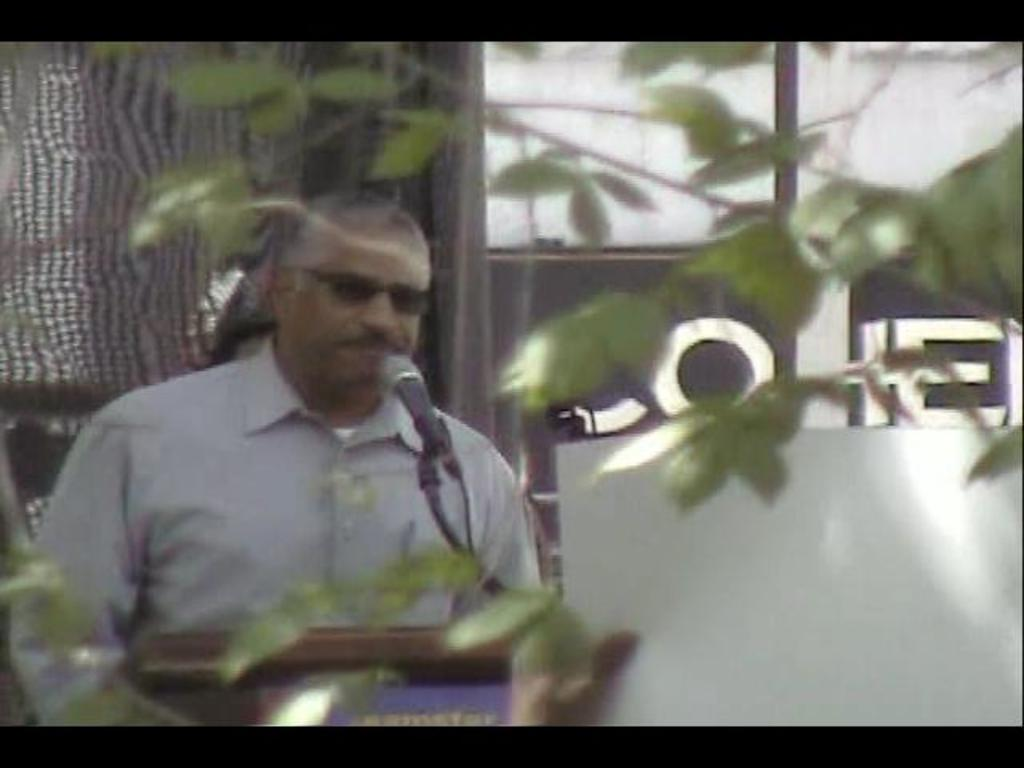What is the person wearing in the image? The person is wearing a white shirt in the image. What object is present that is commonly used for amplifying sound? There is a microphone (mic) in the image. What type of object can be seen in the image that is used for transmitting sound or electricity? There is a wire in the image. What type of vegetation can be seen in the image? There are green leaves visible in the image. What color and pattern can be seen in the background of the image? There is a brown and white color object in the background of the image. How many times does the person push the cent in the image? There is no cent or pushing action present in the image. What type of respect is shown by the person in the image? There is no indication of respect or any specific action related to respect in the image. 